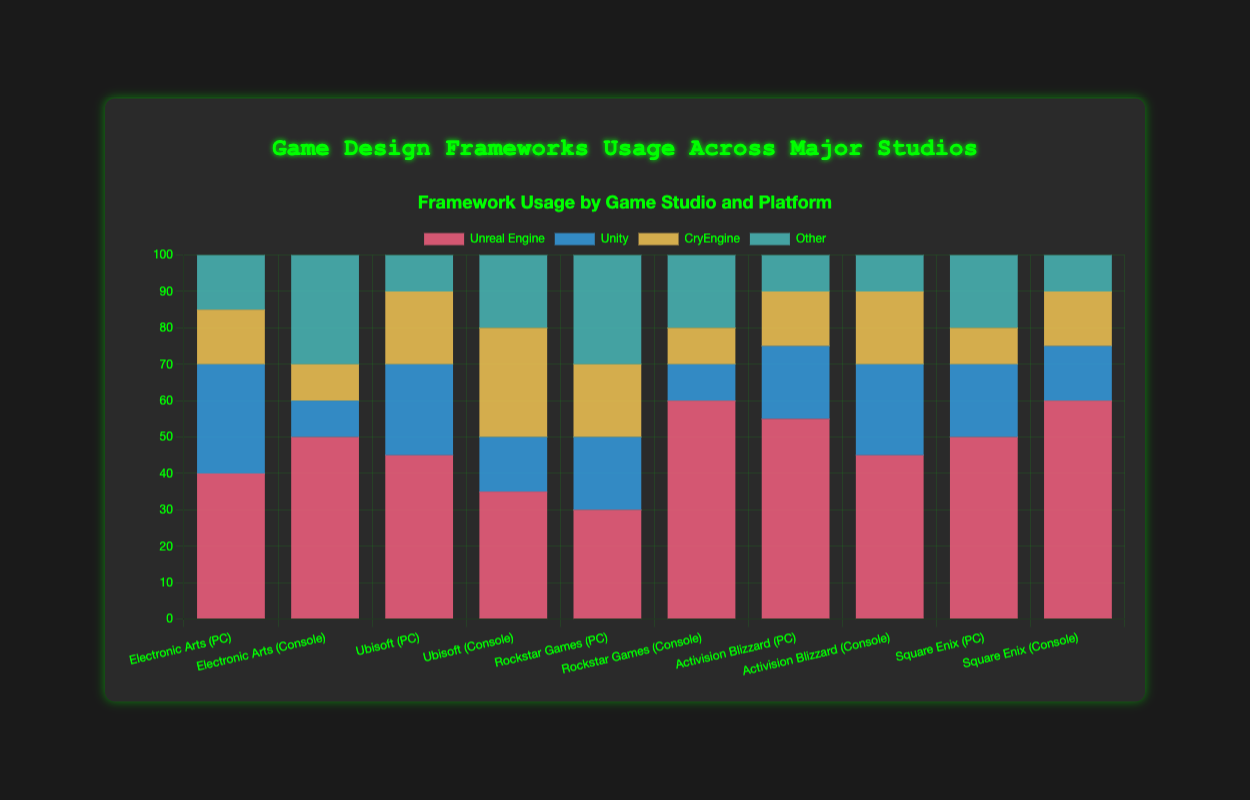Which game studio has the highest usage of Unreal Engine on PC? The chart shows the usage of Unreal Engine for each game studio on both PC and console platforms. Look specifically for PC platform usage. Square Enix has the highest usage at 50%.
Answer: Square Enix Which game studio has the least usage of CryEngine on console? The chart shows the usage of CryEngine for each game studio on the console platform. Look for the game studio with the smallest CryEngine percentage. Electronic Arts and Rockstar Games both have the least usage at 10%.
Answer: Electronic Arts, Rockstar Games What is the total usage percentage of Unity across all platforms for Ubisoft? Add the Unity usage for Ubisoft on both PC and console. For PC, it is 25%, and for console, it is 15%. So, 25% + 15% = 40%.
Answer: 40% How does the usage of Unreal Engine compare between PC and console for Electronic Arts? Look at the usage percentages for Unreal Engine for Electronic Arts on PC and console separately. For PC, it is 40%, and for console, it is 50%. So, Unreal Engine usage is higher on consoles by 10%.
Answer: Higher on consoles by 10% Which genre has the highest combined usage of "Other" frameworks across all game studios and platforms? Sum the "Other" framework usage percentages for each genre across all game studios and platforms. The genres are Action, Sports, RPG, Adventure, and FPS. Calculate for each and compare. The Action genre has the highest combined usage (30% (Rockstar) + 20% (Rockstar) + 15% (EA) + 10% (AB) = 75%).
Answer: Action Do Ubisoft and Activision Blizzard have similar framework usage patterns on PC for any genre? Review the framework usage for Ubisoft and Activision Blizzard on the PC platform. Compare both for any genre. Notice that both studios use similar patterns for RPG and FPS, respectively, despite differing slightly in specific usage percentages.
Answer: Yes (patterns in RPG and FPS) What is the average usage of Unity across all studios for the console platform? Find Unity usage percentages for each game studio on the console platform. They are 10%, 15%, 10%, 25%, and 15%. Calculate the average: (10+15+10+25+15)/5 = 15%.
Answer: 15% Which game studio/platform combination has the lowest usage of "Other" frameworks and what is that percentage? Find the game studio/platform combination with the smallest "Other" framework usage. For "Other", Minimal usage is with Activision Blizzard on both PC and console platforms, each at 10%.
Answer: Activision Blizzard on PC/Console (10%) Compare the usage of CryEngine on console between Rockstar Games and Ubisoft. What is the difference in percentage? Check the CryEngine usage percentages for Rockstar Games and Ubisoft on the console platform. Rockstar Games has 10%, and Ubisoft has 30%. The difference is 30% - 10% = 20%.
Answer: 20% What is the total framework usage for Epic Electronic Arts on all platforms? Sum the percentages for Unreal Engine, Unity, CryEngine, and Other for Electronic Arts on both PC and console platforms. PC: 40+30+15+15=100% and Console: 50+10+10+30=100%. Total for all platforms is still 100% for each genre, as it sums to 100% per platform.
Answer: 100% (per platform) 